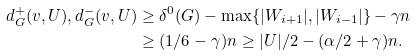Convert formula to latex. <formula><loc_0><loc_0><loc_500><loc_500>d ^ { + } _ { G } ( v , U ) , d ^ { - } _ { G } ( v , U ) & \geq \delta ^ { 0 } ( G ) - \max \{ | W _ { i + 1 } | , | W _ { i - 1 } | \} - \gamma n \\ & \geq ( 1 / 6 - \gamma ) n \geq | U | / 2 - ( \alpha / 2 + \gamma ) n .</formula> 